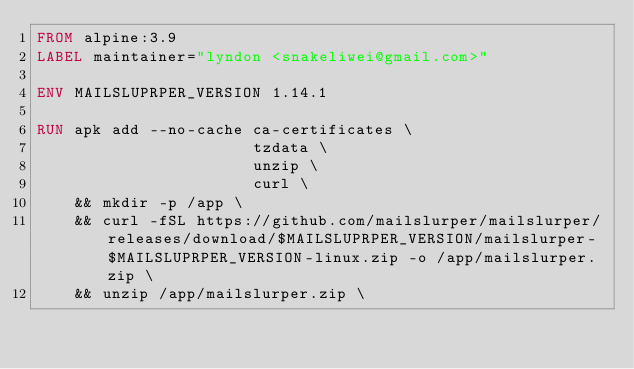Convert code to text. <code><loc_0><loc_0><loc_500><loc_500><_Dockerfile_>FROM alpine:3.9
LABEL maintainer="lyndon <snakeliwei@gmail.com>"

ENV MAILSLUPRPER_VERSION 1.14.1

RUN apk add --no-cache ca-certificates \
                       tzdata \
                       unzip \
                       curl \
    && mkdir -p /app \
    && curl -fSL https://github.com/mailslurper/mailslurper/releases/download/$MAILSLUPRPER_VERSION/mailslurper-$MAILSLUPRPER_VERSION-linux.zip -o /app/mailslurper.zip \
    && unzip /app/mailslurper.zip \</code> 